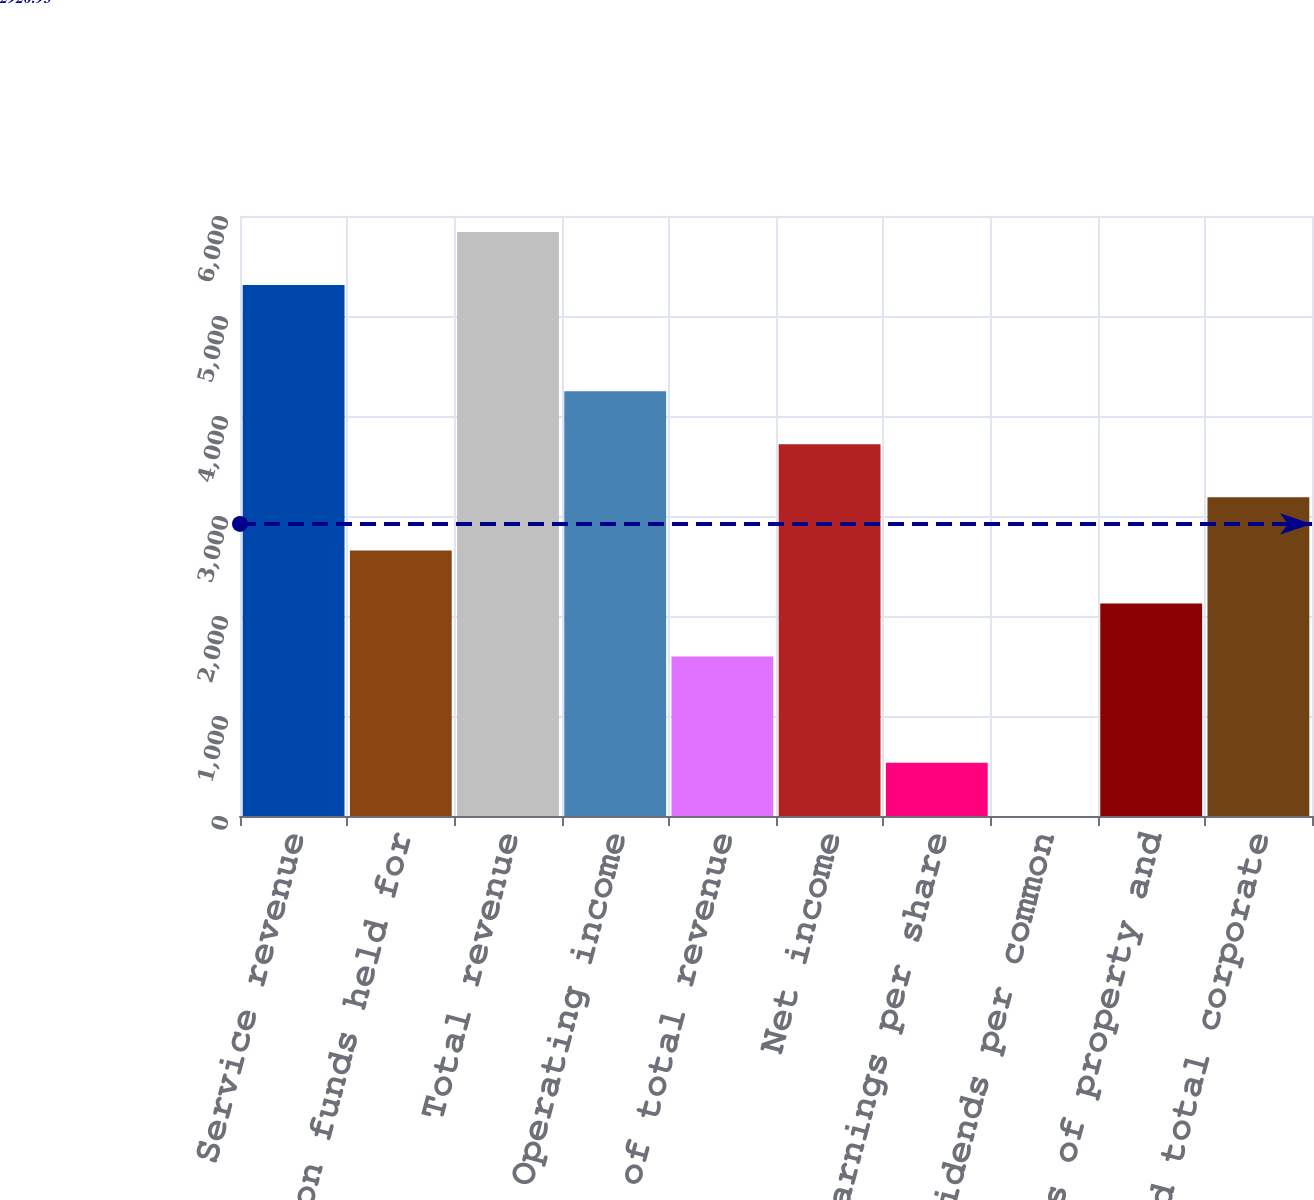<chart> <loc_0><loc_0><loc_500><loc_500><bar_chart><fcel>Service revenue<fcel>Interest on funds held for<fcel>Total revenue<fcel>Operating income<fcel>As a of total revenue<fcel>Net income<fcel>Diluted earnings per share<fcel>Cash dividends per common<fcel>Purchases of property and<fcel>Cash and total corporate<nl><fcel>5309.8<fcel>2655.5<fcel>5840.66<fcel>4248.08<fcel>1593.78<fcel>3717.22<fcel>532.06<fcel>1.2<fcel>2124.64<fcel>3186.36<nl></chart> 